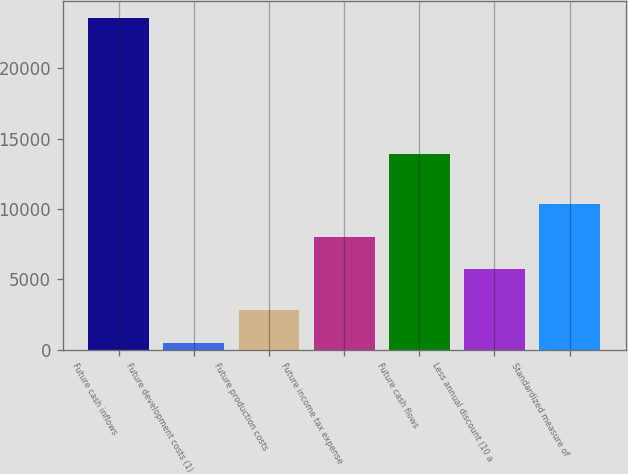Convert chart to OTSL. <chart><loc_0><loc_0><loc_500><loc_500><bar_chart><fcel>Future cash inflows<fcel>Future development costs (1)<fcel>Future production costs<fcel>Future income tax expense<fcel>Future cash flows<fcel>Less annual discount (10 a<fcel>Standardized measure of<nl><fcel>23602<fcel>503<fcel>2812.9<fcel>8032.9<fcel>13899<fcel>5723<fcel>10342.8<nl></chart> 